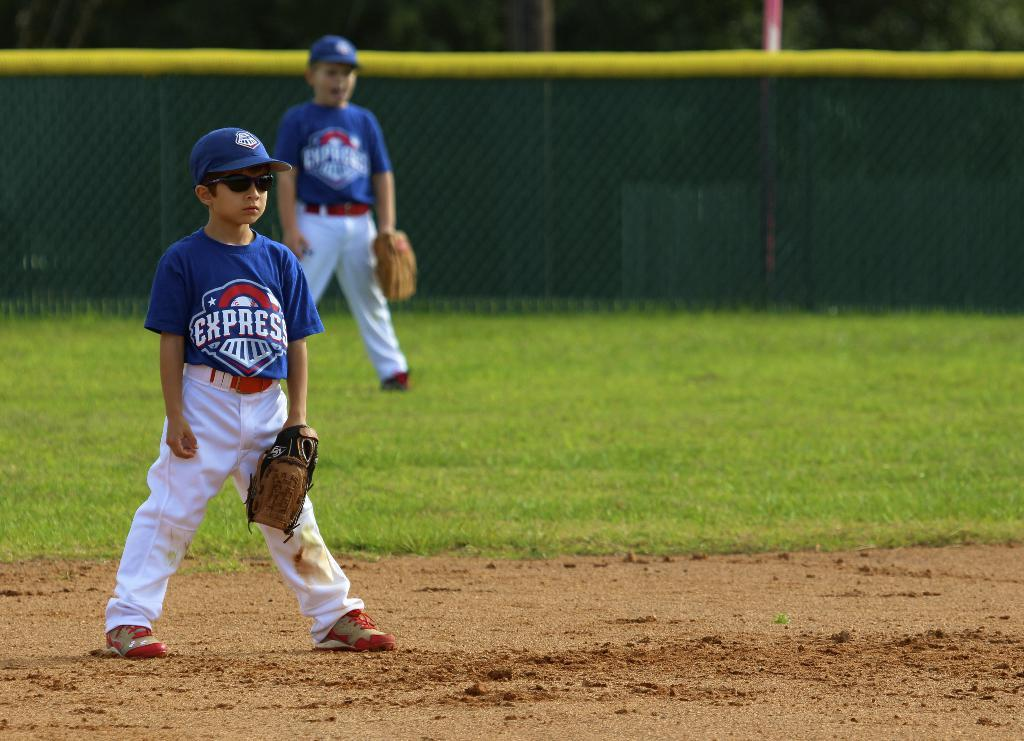<image>
Summarize the visual content of the image. A kid wears a shirt with the word express on a baseball field. 